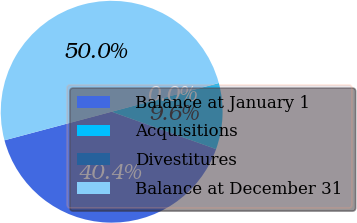Convert chart to OTSL. <chart><loc_0><loc_0><loc_500><loc_500><pie_chart><fcel>Balance at January 1<fcel>Acquisitions<fcel>Divestitures<fcel>Balance at December 31<nl><fcel>40.38%<fcel>9.62%<fcel>0.02%<fcel>49.98%<nl></chart> 